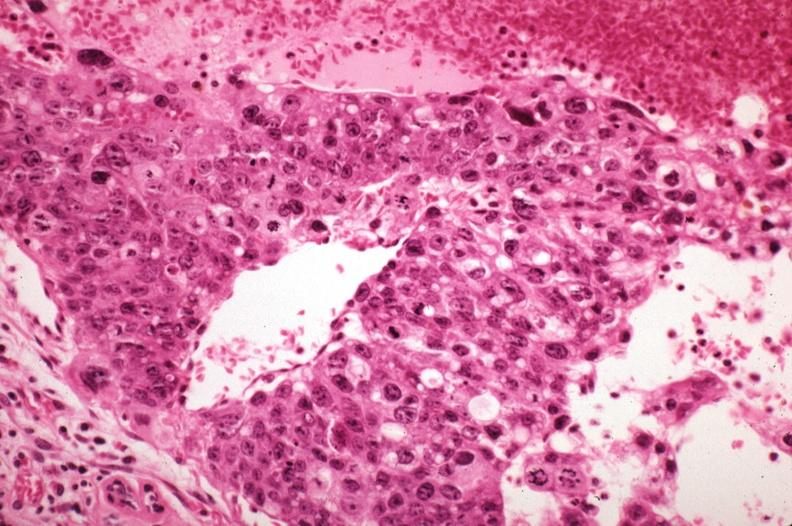what sickled red cells in vessels well shown?
Answer the question using a single word or phrase. Mitotic figures 